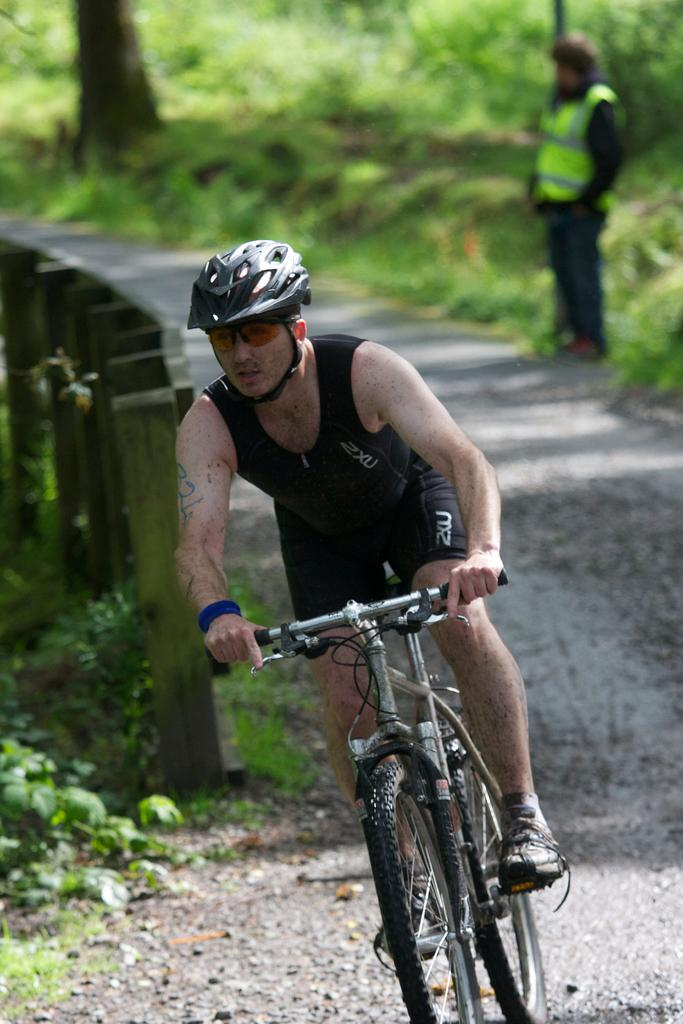Who is the main subject in the image? There is a man in the image. What is the man doing in the image? The man is riding a bicycle. What can be seen behind the man in the image? There is a fence behind the man. What type of natural elements are visible in the image? There are trees visible in the image. What color are the man's eyes in the image? The image does not show the man's eyes, so we cannot determine their color. 